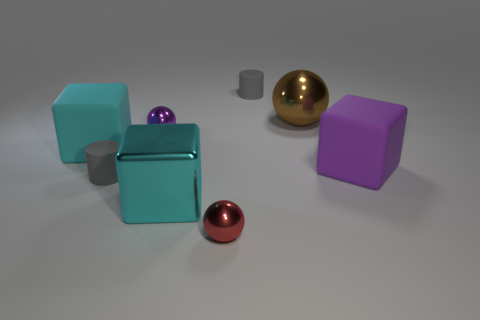What size is the other cube that is the same color as the shiny block?
Offer a terse response. Large. The large rubber object that is the same color as the big metal cube is what shape?
Keep it short and to the point. Cube. What color is the large matte thing right of the tiny rubber object that is left of the tiny matte cylinder behind the big ball?
Offer a very short reply. Purple. What is the shape of the tiny gray rubber thing that is in front of the tiny cylinder that is right of the red thing?
Your response must be concise. Cylinder. Are there more metal spheres that are on the left side of the large purple rubber cube than small blue metallic blocks?
Make the answer very short. Yes. Do the gray rubber object that is on the right side of the purple sphere and the large purple thing have the same shape?
Your response must be concise. No. Are there any purple shiny objects that have the same shape as the small red thing?
Offer a very short reply. Yes. What number of objects are either gray cylinders behind the large brown object or tiny rubber things?
Your response must be concise. 2. Is the number of brown objects greater than the number of tiny purple rubber cylinders?
Your response must be concise. Yes. Is there a cyan shiny thing of the same size as the cyan matte thing?
Offer a terse response. Yes. 